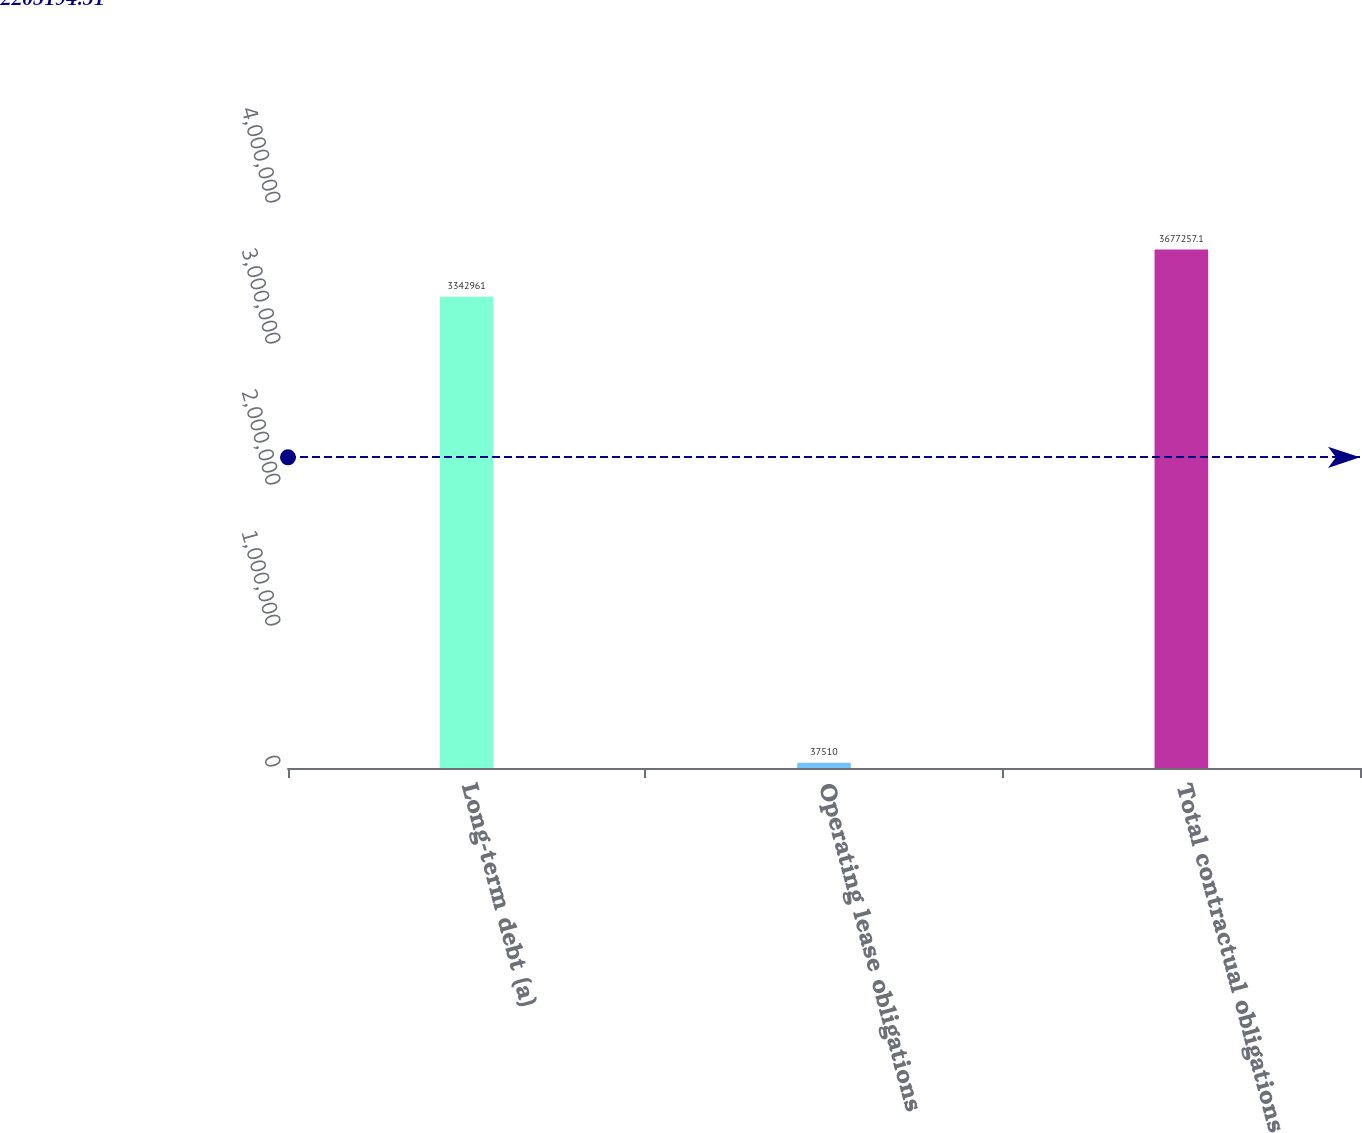Convert chart. <chart><loc_0><loc_0><loc_500><loc_500><bar_chart><fcel>Long-term debt (a)<fcel>Operating lease obligations<fcel>Total contractual obligations<nl><fcel>3.34296e+06<fcel>37510<fcel>3.67726e+06<nl></chart> 